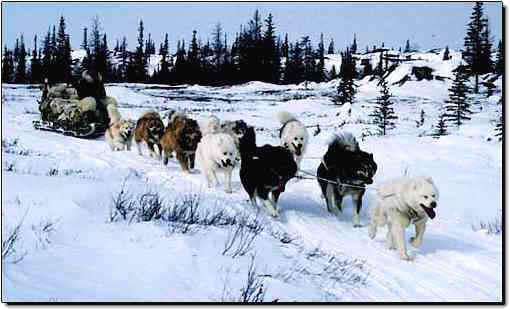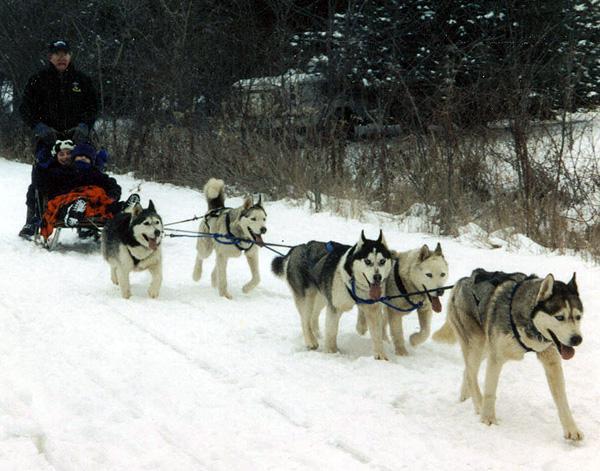The first image is the image on the left, the second image is the image on the right. Analyze the images presented: Is the assertion "The dogs are heading toward the left in the image on the right." valid? Answer yes or no. No. The first image is the image on the left, the second image is the image on the right. Given the left and right images, does the statement "Both images show sled dog teams headed rightward and downward." hold true? Answer yes or no. Yes. 